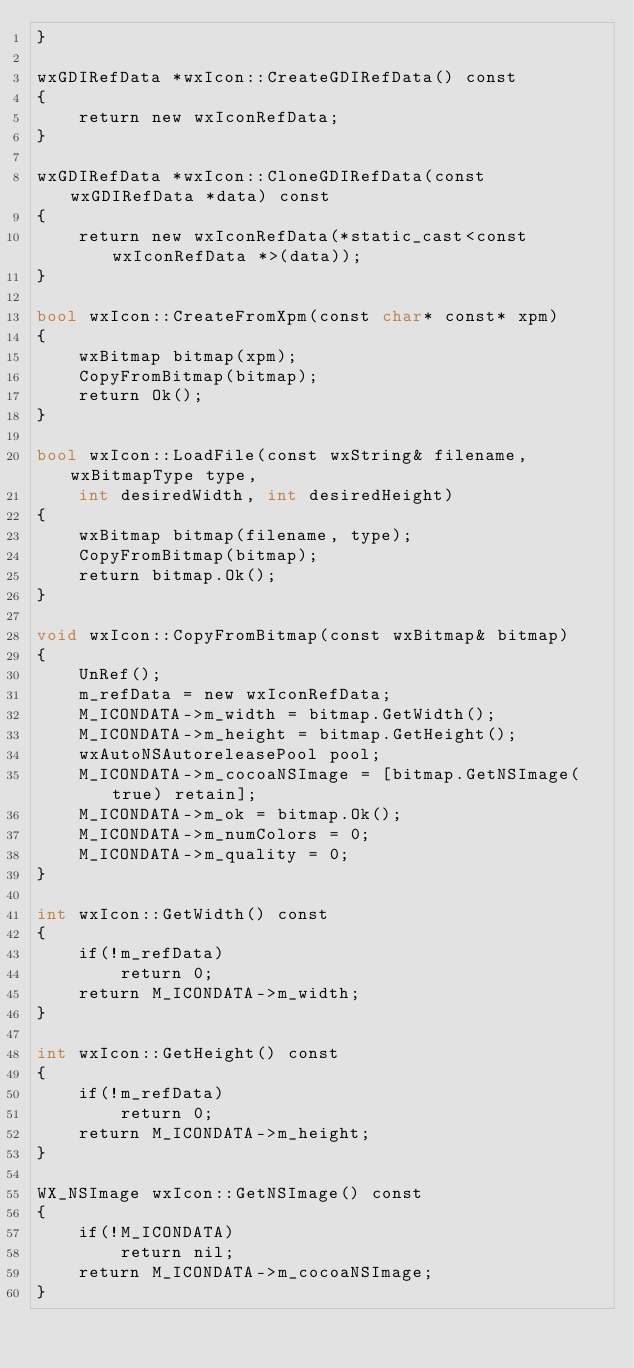<code> <loc_0><loc_0><loc_500><loc_500><_ObjectiveC_>}

wxGDIRefData *wxIcon::CreateGDIRefData() const
{
    return new wxIconRefData;
}

wxGDIRefData *wxIcon::CloneGDIRefData(const wxGDIRefData *data) const
{
    return new wxIconRefData(*static_cast<const wxIconRefData *>(data));
}

bool wxIcon::CreateFromXpm(const char* const* xpm)
{
    wxBitmap bitmap(xpm);
    CopyFromBitmap(bitmap);
    return Ok();
}

bool wxIcon::LoadFile(const wxString& filename, wxBitmapType type,
    int desiredWidth, int desiredHeight)
{
    wxBitmap bitmap(filename, type);
    CopyFromBitmap(bitmap);
    return bitmap.Ok();
}

void wxIcon::CopyFromBitmap(const wxBitmap& bitmap)
{
    UnRef();
    m_refData = new wxIconRefData;
    M_ICONDATA->m_width = bitmap.GetWidth();
    M_ICONDATA->m_height = bitmap.GetHeight();
    wxAutoNSAutoreleasePool pool;
    M_ICONDATA->m_cocoaNSImage = [bitmap.GetNSImage(true) retain];
    M_ICONDATA->m_ok = bitmap.Ok();
    M_ICONDATA->m_numColors = 0;
    M_ICONDATA->m_quality = 0;
}

int wxIcon::GetWidth() const
{
    if(!m_refData)
        return 0;
    return M_ICONDATA->m_width;
}

int wxIcon::GetHeight() const
{
    if(!m_refData)
        return 0;
    return M_ICONDATA->m_height;
}

WX_NSImage wxIcon::GetNSImage() const
{
    if(!M_ICONDATA)
        return nil;
    return M_ICONDATA->m_cocoaNSImage;
}
</code> 